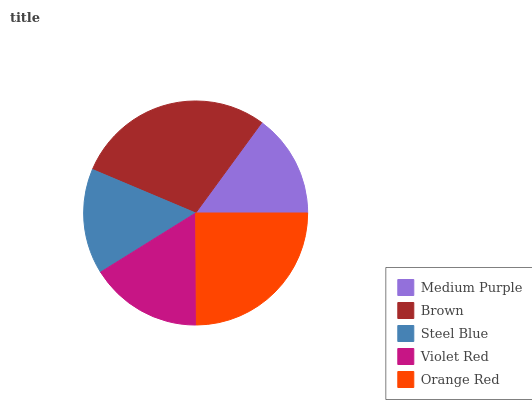Is Medium Purple the minimum?
Answer yes or no. Yes. Is Brown the maximum?
Answer yes or no. Yes. Is Steel Blue the minimum?
Answer yes or no. No. Is Steel Blue the maximum?
Answer yes or no. No. Is Brown greater than Steel Blue?
Answer yes or no. Yes. Is Steel Blue less than Brown?
Answer yes or no. Yes. Is Steel Blue greater than Brown?
Answer yes or no. No. Is Brown less than Steel Blue?
Answer yes or no. No. Is Violet Red the high median?
Answer yes or no. Yes. Is Violet Red the low median?
Answer yes or no. Yes. Is Orange Red the high median?
Answer yes or no. No. Is Brown the low median?
Answer yes or no. No. 